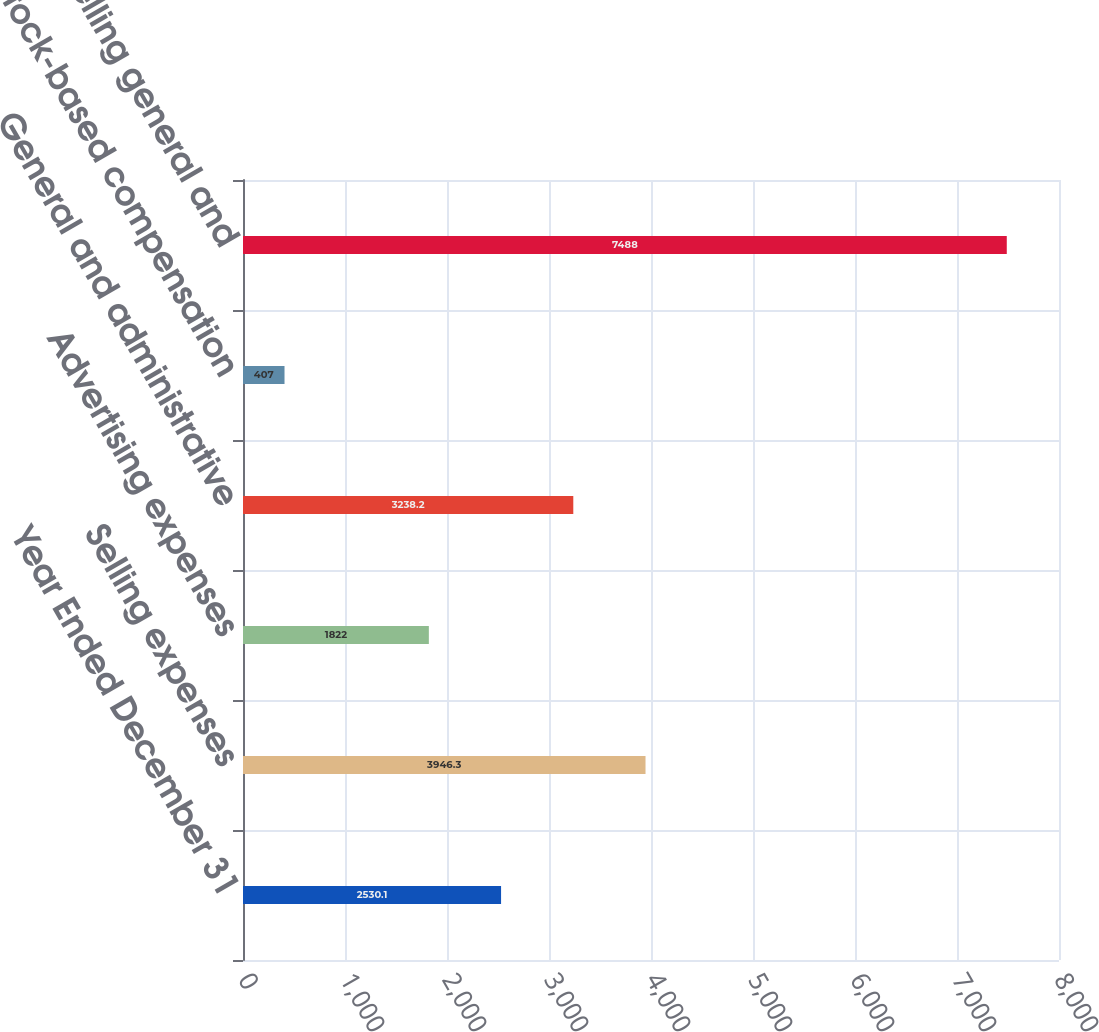Convert chart to OTSL. <chart><loc_0><loc_0><loc_500><loc_500><bar_chart><fcel>Year Ended December 31<fcel>Selling expenses<fcel>Advertising expenses<fcel>General and administrative<fcel>Stock-based compensation<fcel>Selling general and<nl><fcel>2530.1<fcel>3946.3<fcel>1822<fcel>3238.2<fcel>407<fcel>7488<nl></chart> 